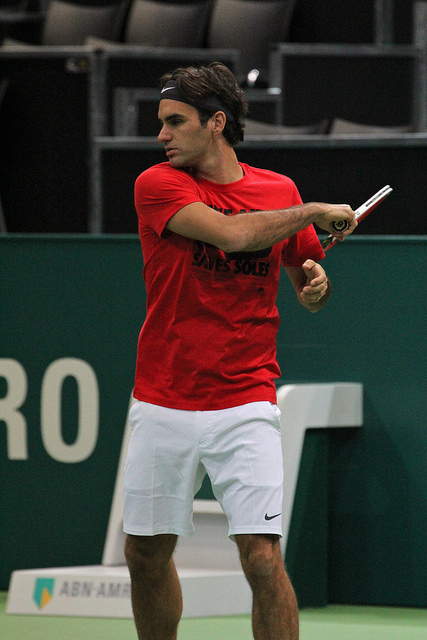Please identify all text content in this image. RO SAVES SOLES ABN 